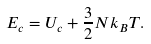Convert formula to latex. <formula><loc_0><loc_0><loc_500><loc_500>E _ { c } = U _ { c } + \frac { 3 } { 2 } N k _ { B } T .</formula> 